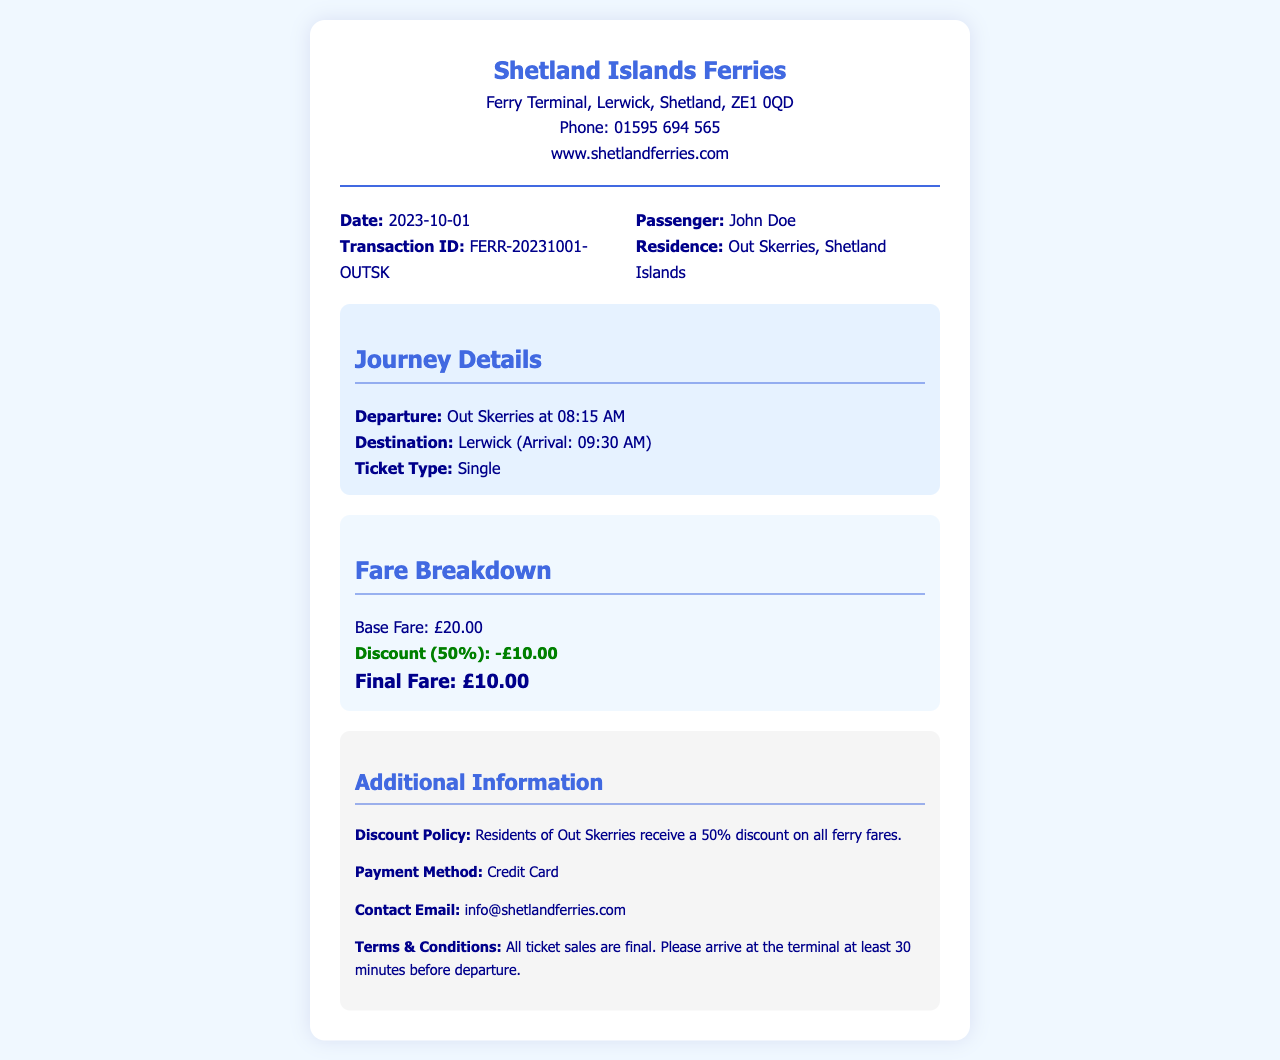What is the date of the transaction? The date of the transaction is specified in the receipt details section.
Answer: 2023-10-01 What is the passenger's name? The passenger's name is provided in the receipt details section.
Answer: John Doe What was the base fare for the ticket? The base fare is outlined in the fare breakdown section of the receipt.
Answer: £20.00 What type of ticket was purchased? The ticket type is mentioned in the journey details section.
Answer: Single What discount percentage do residents of Out Skerries receive? The discount policy states the percentage of the discount for residents.
Answer: 50% What is the final fare after the discount? The final fare is calculated in the fare breakdown section after applying the discount.
Answer: £10.00 What time was the departure from Out Skerries? The departure time is listed in the journey details section.
Answer: 08:15 AM What is the payment method used for the ticket? The payment method is stated in the additional information section of the receipt.
Answer: Credit Card What is the contact email for inquiries? The contact email is provided in the additional information section.
Answer: info@shetlandferries.com 